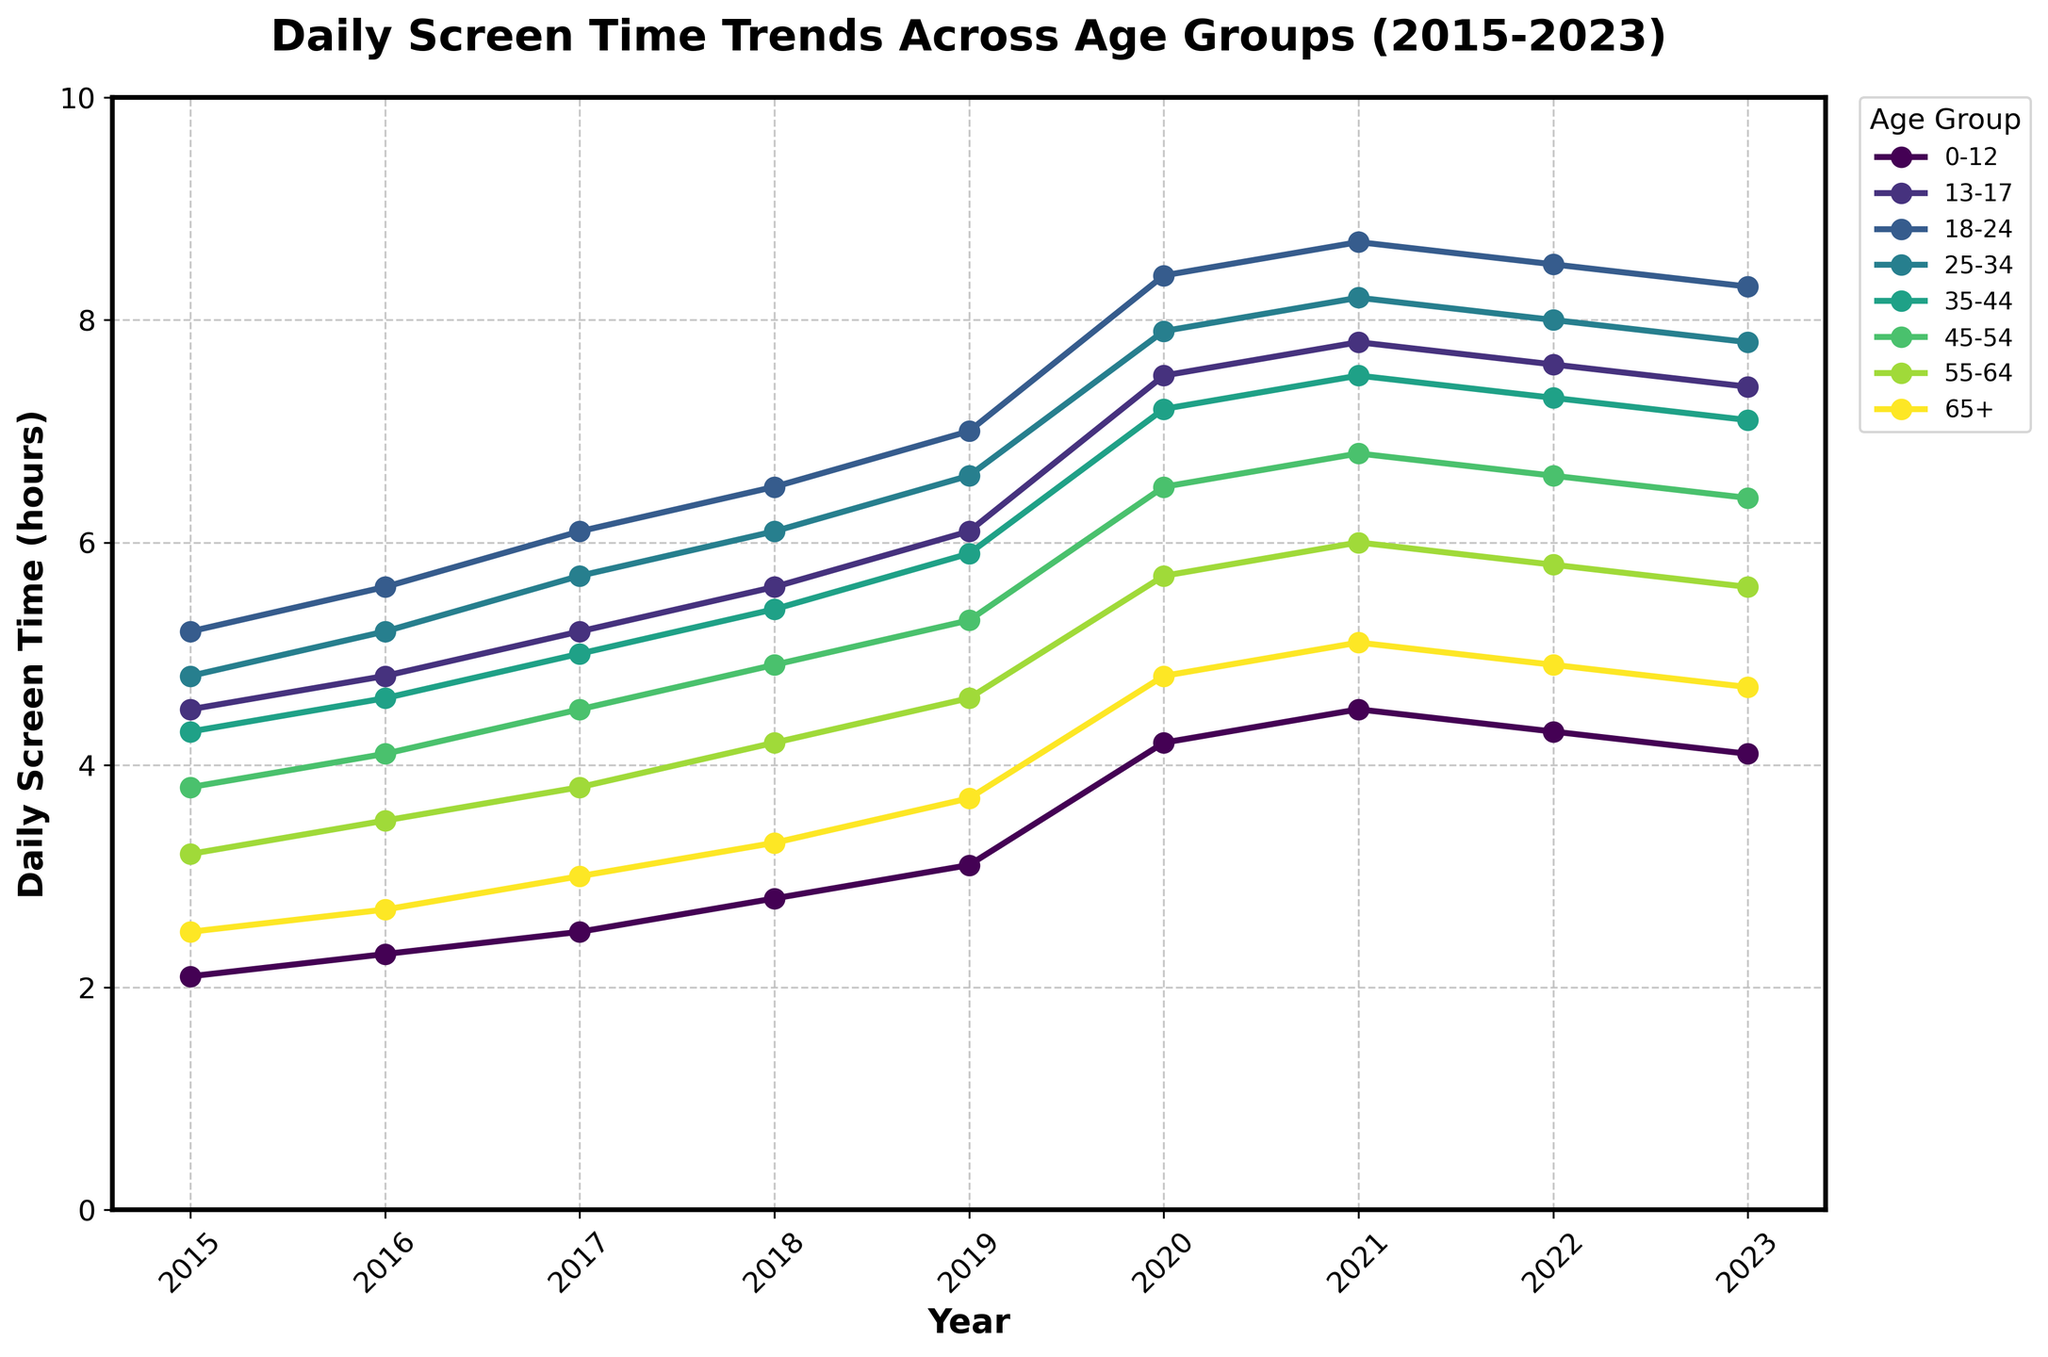What year did screen time for the 0-12 age group first exceed 3 hours? To find the first year the screen time for the 0-12 age group exceeded 3 hours, examine the data points in the figure for 0-12 age group. 2019 has a value of 3.1, which is the first year it exceeds 3 hours.
Answer: 2019 Which age group saw the largest increase in daily screen time between 2019 and 2020? To determine which age group saw the largest increase, calculate the change in screen time from 2019 to 2020 for each age group. The 0-12 age group's screen time increased from 3.1 to 4.2 hours, a difference of 1.1 hours, which is the largest increase.
Answer: 0-12 What was the average daily screen time for the 25-34 age group over the period shown? To find the average, sum the 25-34 age group's screen time values and then divide by the number of years. (4.8 + 5.2 + 5.7 + 6.1 + 6.6 + 7.9 + 8.2 + 8.0 + 7.8) / 9 = 6.03
Answer: 6.03 hours Did the daily screen time for the 45-54 age group ever exceed that of the 18-24 age group? Compare the screen time values of the 45-54 and 18-24 age groups across all years. The 18-24 age group always had higher screen time values than the 45-54 age group, so it never exceeded.
Answer: No What is the difference between the highest and lowest screen times for the 65+ age group? Identify the highest (5.1 in 2021) and lowest (2.5 in 2015) screen times for the 65+ age group, then find the difference. 5.1 - 2.5 = 2.6
Answer: 2.6 hours Between which consecutive years did the 13-17 age group experience the largest drop in screen time? Calculate the difference in screen time between each pair of consecutive years for the 13-17 age group. The largest drop is between 2021 and 2022, where it goes from 7.8 to 7.6, a drop of 0.2.
Answer: 2021-2022 Which age group had the least increase in screen time from 2015 to 2023? Calculate the overall increase from 2015 to 2023 for each age group. The 0-12 age group increased from 2.1 to 4.1, a total of 2 hours, which is the smallest increase.
Answer: 0-12 In which year did the 35-44 age group reach its peak daily screen time? Look at the screen time values for the 35-44 age group and identify the year with the highest value. The peak of 7.5 hours occurs in 2021.
Answer: 2021 How does the screen time of the 55-64 age group in 2020 compare to that of the 0-12 group in 2023? Compare the screen time values for the 55-64 age group in 2020 (5.7 hours) to the 0-12 age group in 2023 (4.1 hours). The 55-64 age group had more screen time in 2020 by 5.7 - 4.1 = 1.6 hours.
Answer: 1.6 hours more 